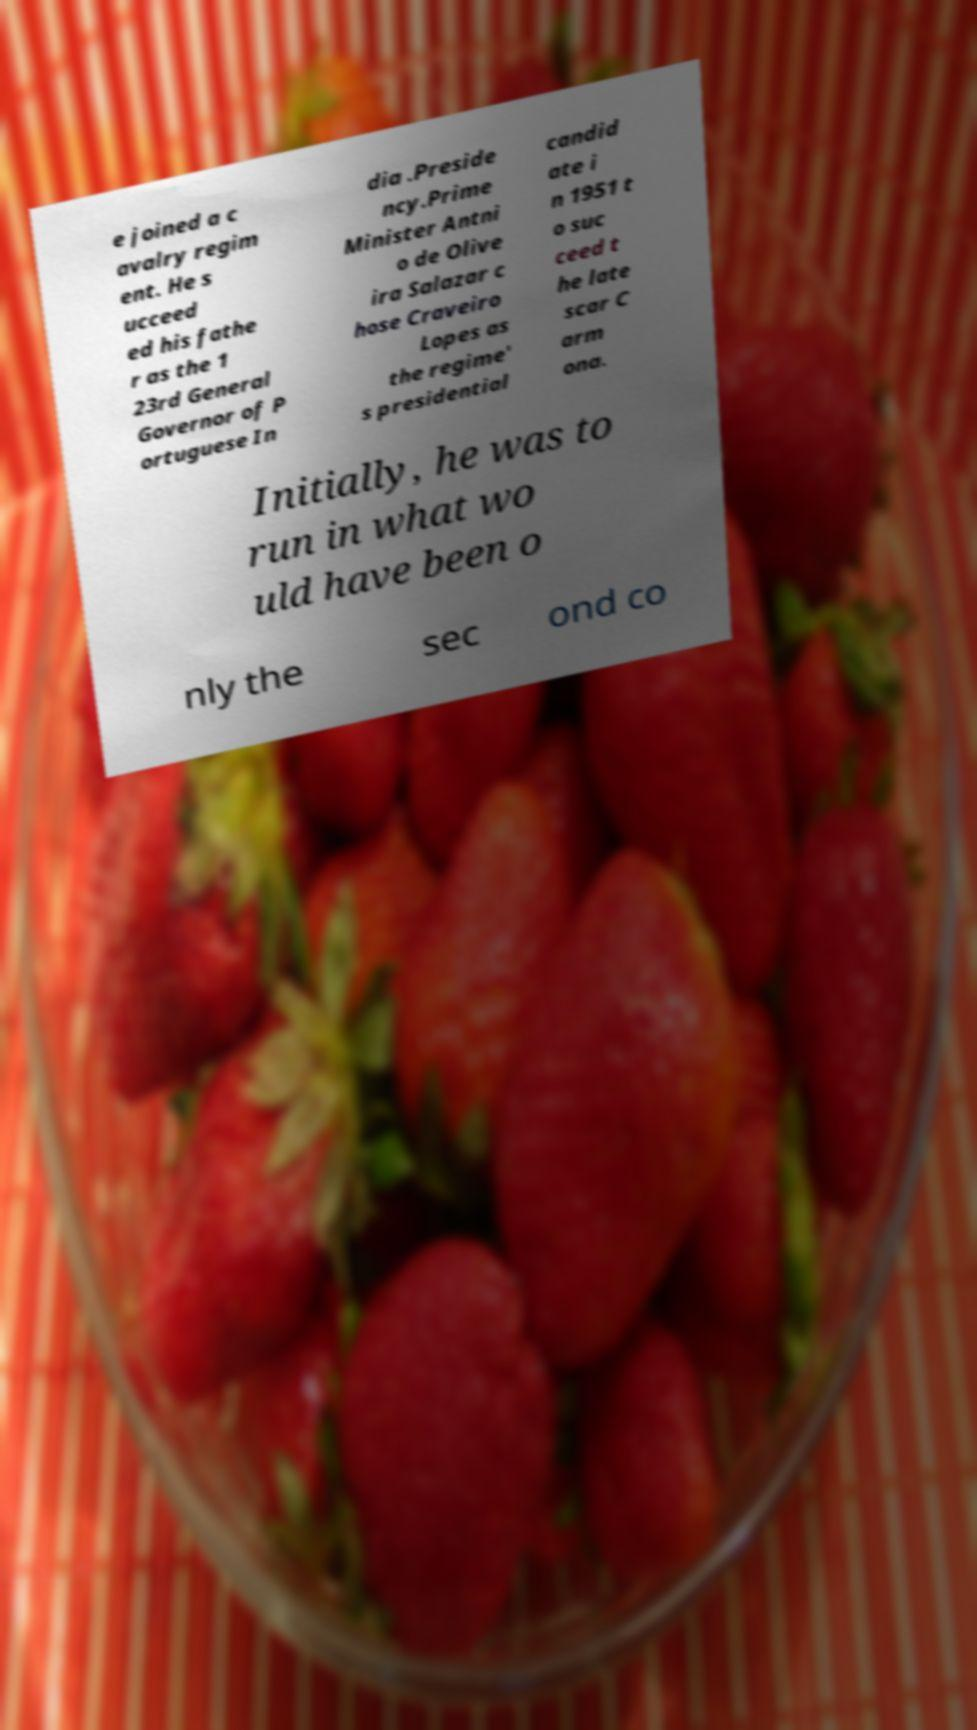Can you read and provide the text displayed in the image?This photo seems to have some interesting text. Can you extract and type it out for me? e joined a c avalry regim ent. He s ucceed ed his fathe r as the 1 23rd General Governor of P ortuguese In dia .Preside ncy.Prime Minister Antni o de Olive ira Salazar c hose Craveiro Lopes as the regime' s presidential candid ate i n 1951 t o suc ceed t he late scar C arm ona. Initially, he was to run in what wo uld have been o nly the sec ond co 